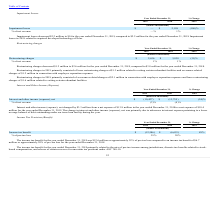According to Maxlinear's financial document, What was the net expense in the year ended December 31, 2018? According to the financial document, $13.8 million. The relevant text states: "net changed by $3.3 million from a net expense of $13.8 million in the year ended December 31, 2018 to a net expense of $10.4..." Also, What was the net expense in the year ended December 31, 2019? Based on the financial document, the answer is $10.4 million. Also, What led to change in interest and other income (expense), net? primarily due to a decrease in interest expense pertaining to a lower average balance of debt outstanding under our term loan facility during the year.. The document states: "ge in interest and other income (expense), net was primarily due to a decrease in interest expense pertaining to a lower average balance of debt outst..." Also, can you calculate: What is the average Interest and other income (expense), net for the year ended December 31, 2019 to 2018? To answer this question, I need to perform calculations using the financial data. The calculation is: -(10,427+13,755) / 2, which equals -12091 (in thousands). This is based on the information: "Interest and other income (expense), net $ (10,427) $ (13,755) (24)% est and other income (expense), net $ (10,427) $ (13,755) (24)%..." The key data points involved are: 10,427, 13,755. Also, can you calculate: What is the average % of net revenue for the year ended December 31, 2019 to 2018? To answer this question, I need to perform calculations using the financial data. The calculation is: (3+4) / 2, which equals 3.5 (percentage). This is based on the information: "Interest and other income (expense), net $ (10,427) $ (13,755) (24)% Year Ended December 31, % Change..." The key data points involved are: 4. Also, can you calculate: What is the change in Interest and other income (expense), net from the year ended December 31, 2019 to 2018? Based on the calculation: -10,427-(13,755), the result is 3328 (in thousands). This is based on the information: "Interest and other income (expense), net $ (10,427) $ (13,755) (24)% est and other income (expense), net $ (10,427) $ (13,755) (24)%..." The key data points involved are: 10,427, 13,755. 